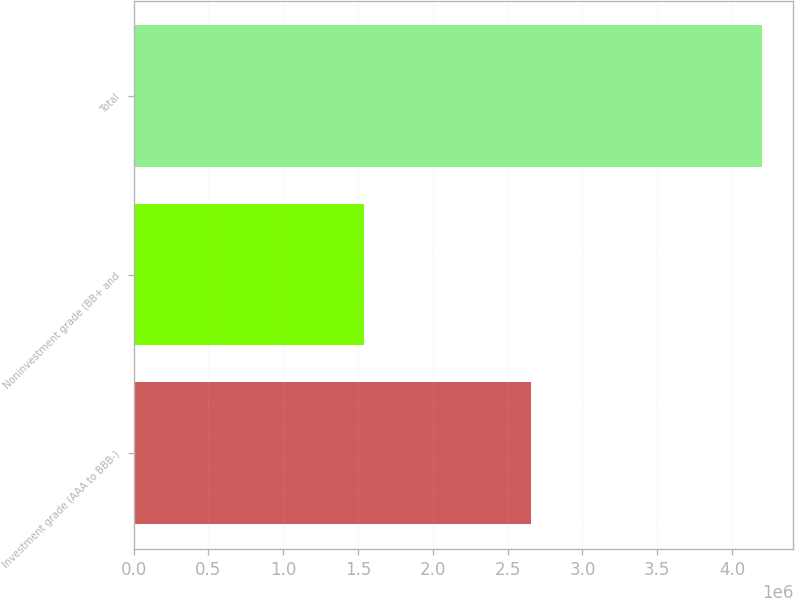Convert chart. <chart><loc_0><loc_0><loc_500><loc_500><bar_chart><fcel>Investment grade (AAA to BBB-)<fcel>Noninvestment grade (BB+ and<fcel>Total<nl><fcel>2.65796e+06<fcel>1.54203e+06<fcel>4.2e+06<nl></chart> 